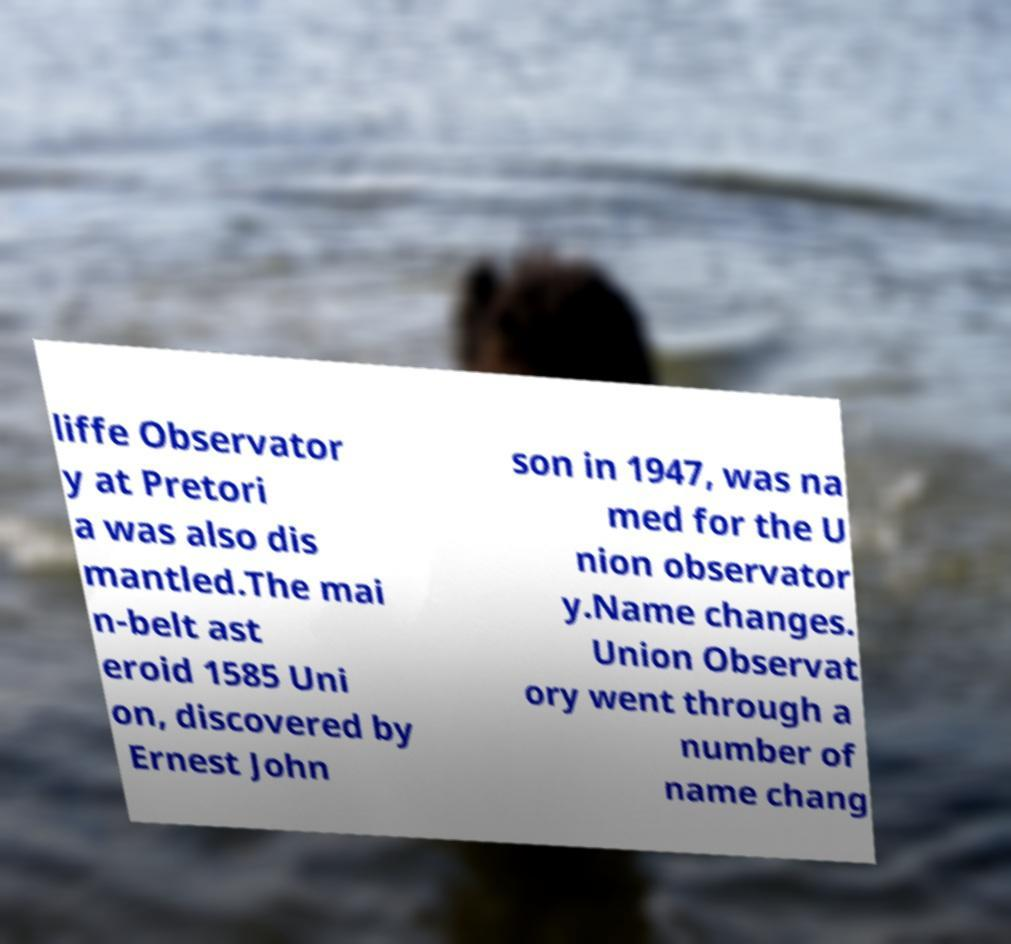Please identify and transcribe the text found in this image. liffe Observator y at Pretori a was also dis mantled.The mai n-belt ast eroid 1585 Uni on, discovered by Ernest John son in 1947, was na med for the U nion observator y.Name changes. Union Observat ory went through a number of name chang 